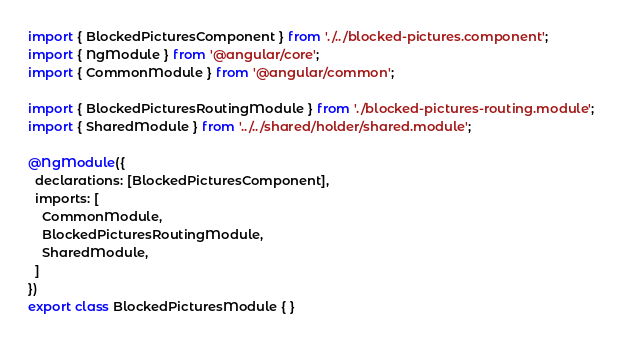Convert code to text. <code><loc_0><loc_0><loc_500><loc_500><_TypeScript_>import { BlockedPicturesComponent } from './../blocked-pictures.component';
import { NgModule } from '@angular/core';
import { CommonModule } from '@angular/common';

import { BlockedPicturesRoutingModule } from './blocked-pictures-routing.module';
import { SharedModule } from '../../shared/holder/shared.module';

@NgModule({
  declarations: [BlockedPicturesComponent],
  imports: [
    CommonModule,
    BlockedPicturesRoutingModule,
    SharedModule,
  ]
})
export class BlockedPicturesModule { }
</code> 